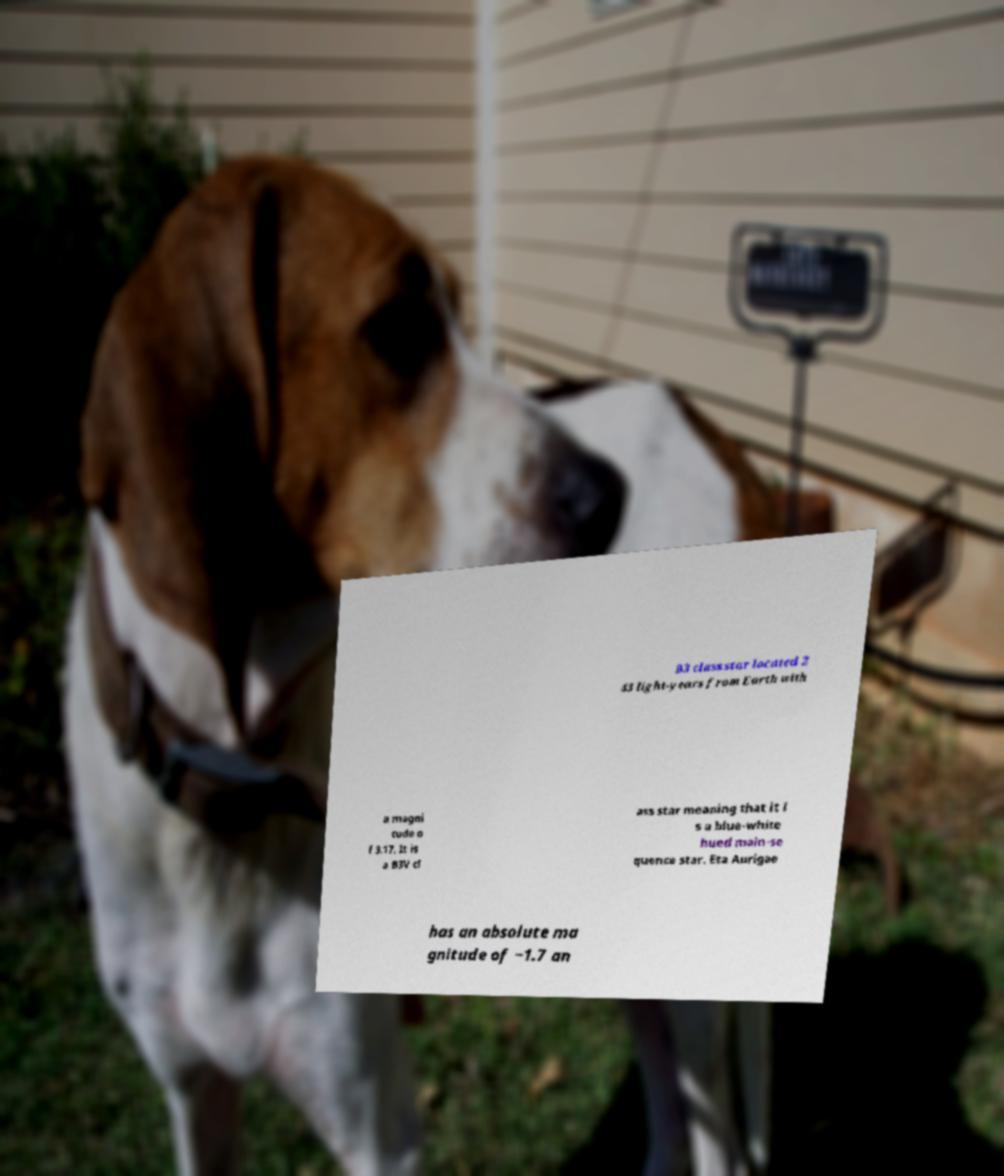What messages or text are displayed in this image? I need them in a readable, typed format. B3 class star located 2 43 light-years from Earth with a magni tude o f 3.17. It is a B3V cl ass star meaning that it i s a blue-white hued main-se quence star. Eta Aurigae has an absolute ma gnitude of −1.7 an 